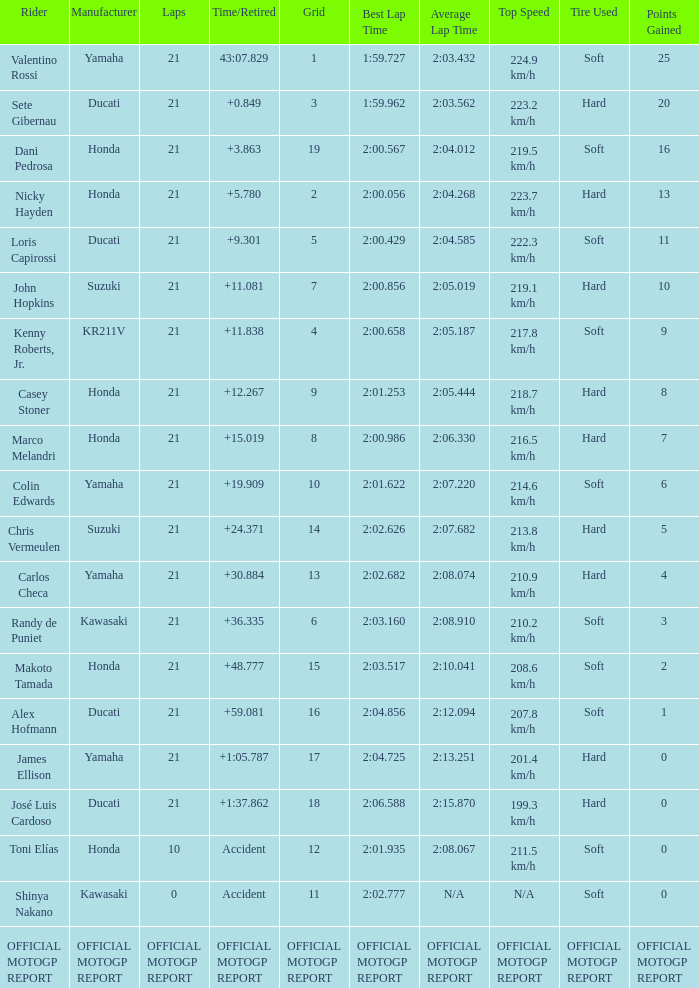What is the time/retired for the rider with the manufacturuer yamaha, grod of 1 and 21 total laps? 43:07.829. 